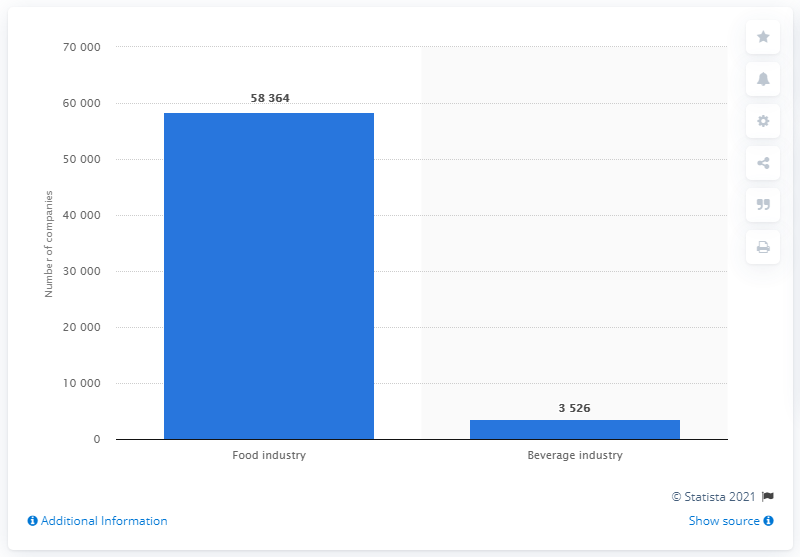Point out several critical features in this image. In the second quarter of 2017, there were 58,364 companies in the food and beverage industry in Italy. 